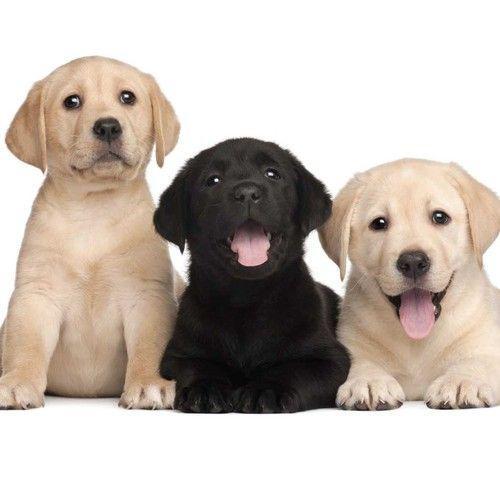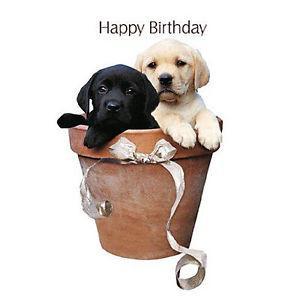The first image is the image on the left, the second image is the image on the right. Given the left and right images, does the statement "there are five dogs in the image on the right." hold true? Answer yes or no. No. The first image is the image on the left, the second image is the image on the right. Considering the images on both sides, is "One image shows exactly two puppies, including a black one." valid? Answer yes or no. Yes. 